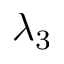Convert formula to latex. <formula><loc_0><loc_0><loc_500><loc_500>\lambda _ { 3 }</formula> 